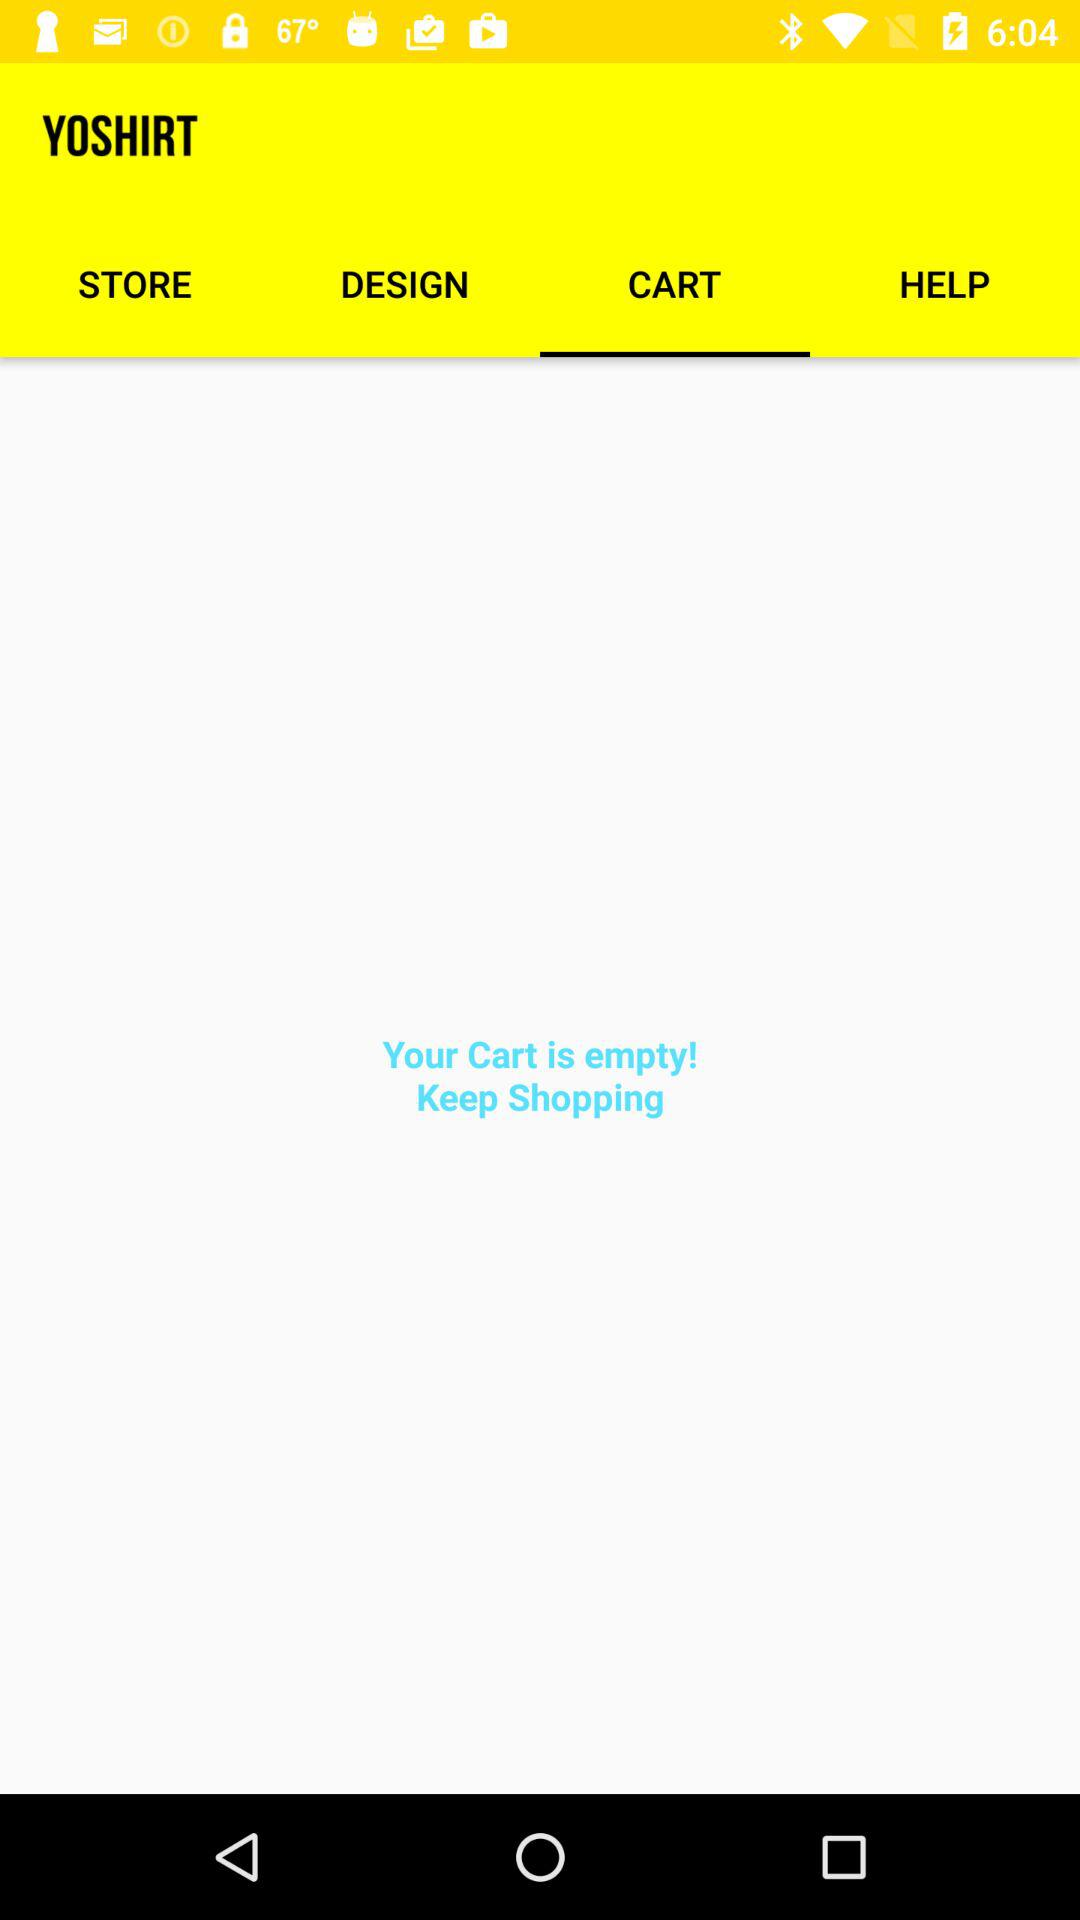Which tab am I using? You are using the "CART" tab. 